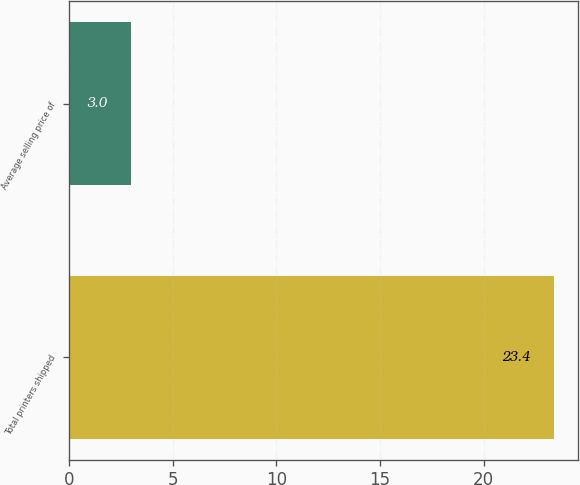Convert chart to OTSL. <chart><loc_0><loc_0><loc_500><loc_500><bar_chart><fcel>Total printers shipped<fcel>Average selling price of<nl><fcel>23.4<fcel>3<nl></chart> 